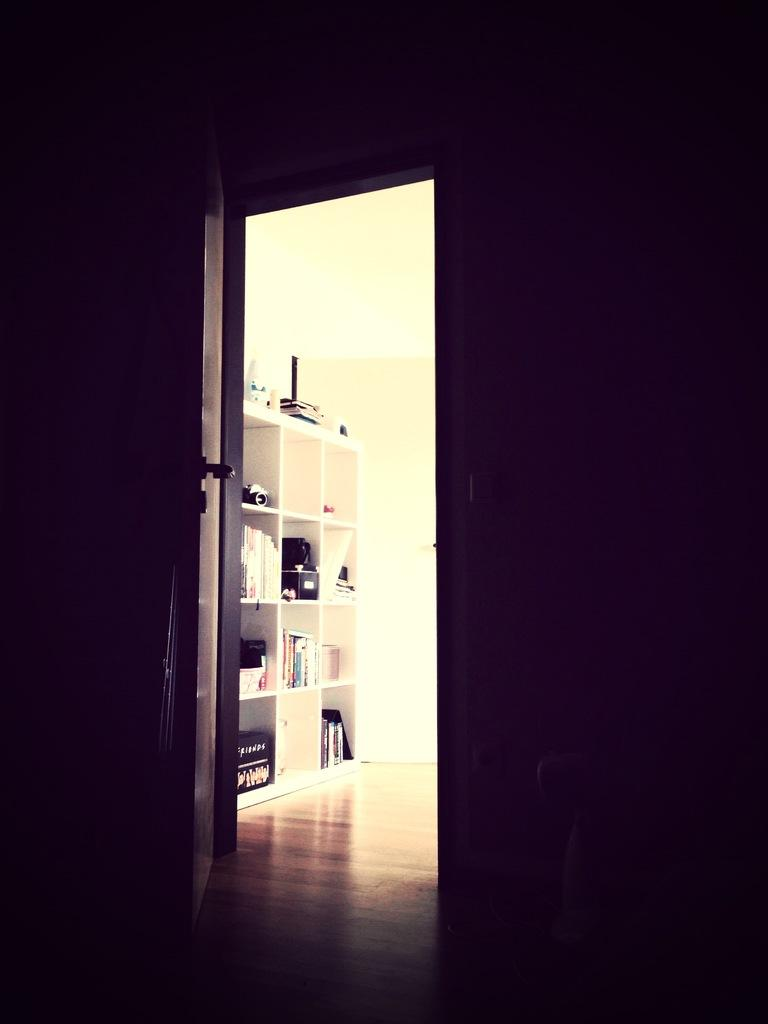What is one of the main structures visible in the image? There is a door in the image. What can be seen on or near the walls in the image? There are objects in racks in the image. What type of background is present in the image? There is a wall in the image. Can you see a flock of birds flying through the door in the image? There is no flock of birds visible in the image; it only features a door, objects in racks, and a wall. Is there any oatmeal being served on the wall in the image? There is no oatmeal present in the image; it only features a door, objects in racks, and a wall. 